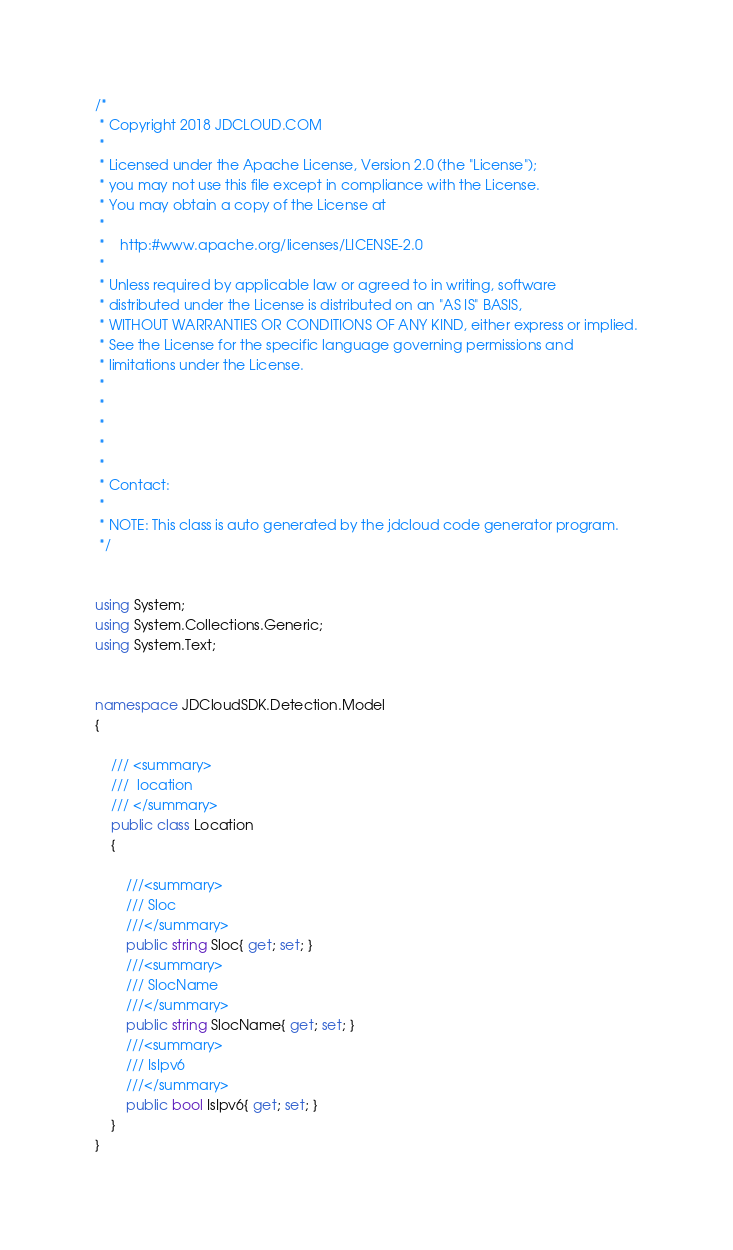Convert code to text. <code><loc_0><loc_0><loc_500><loc_500><_C#_>/*
 * Copyright 2018 JDCLOUD.COM
 *
 * Licensed under the Apache License, Version 2.0 (the "License");
 * you may not use this file except in compliance with the License.
 * You may obtain a copy of the License at
 *
 *    http:#www.apache.org/licenses/LICENSE-2.0
 *
 * Unless required by applicable law or agreed to in writing, software
 * distributed under the License is distributed on an "AS IS" BASIS,
 * WITHOUT WARRANTIES OR CONDITIONS OF ANY KIND, either express or implied.
 * See the License for the specific language governing permissions and
 * limitations under the License.
 *
 * 
 * 
 *
 * 
 * Contact: 
 *
 * NOTE: This class is auto generated by the jdcloud code generator program.
 */


using System;
using System.Collections.Generic;
using System.Text;


namespace JDCloudSDK.Detection.Model
{

    /// <summary>
    ///  location
    /// </summary>
    public class Location
    {

        ///<summary>
        /// Sloc
        ///</summary>
        public string Sloc{ get; set; }
        ///<summary>
        /// SlocName
        ///</summary>
        public string SlocName{ get; set; }
        ///<summary>
        /// IsIpv6
        ///</summary>
        public bool IsIpv6{ get; set; }
    }
}
</code> 